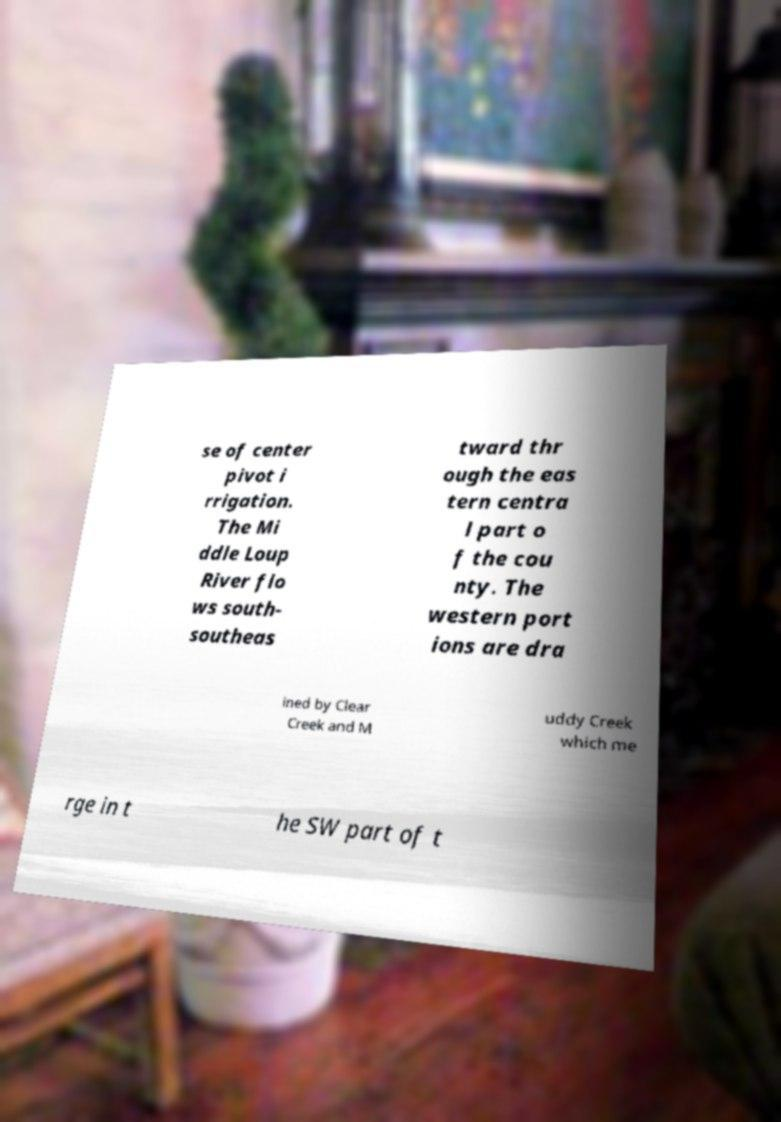Could you extract and type out the text from this image? se of center pivot i rrigation. The Mi ddle Loup River flo ws south- southeas tward thr ough the eas tern centra l part o f the cou nty. The western port ions are dra ined by Clear Creek and M uddy Creek which me rge in t he SW part of t 